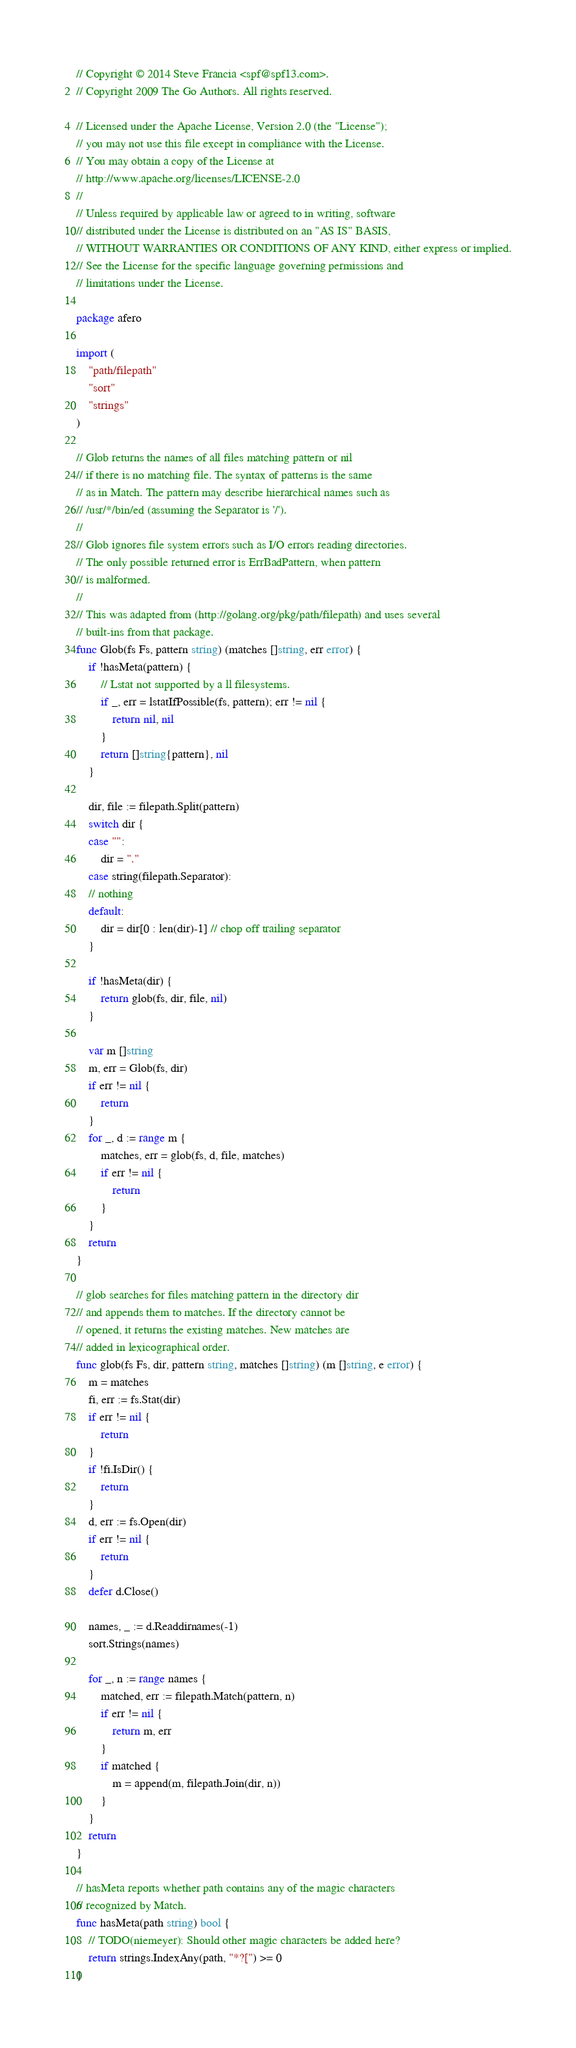Convert code to text. <code><loc_0><loc_0><loc_500><loc_500><_Go_>// Copyright © 2014 Steve Francia <spf@spf13.com>.
// Copyright 2009 The Go Authors. All rights reserved.

// Licensed under the Apache License, Version 2.0 (the "License");
// you may not use this file except in compliance with the License.
// You may obtain a copy of the License at
// http://www.apache.org/licenses/LICENSE-2.0
//
// Unless required by applicable law or agreed to in writing, software
// distributed under the License is distributed on an "AS IS" BASIS,
// WITHOUT WARRANTIES OR CONDITIONS OF ANY KIND, either express or implied.
// See the License for the specific language governing permissions and
// limitations under the License.

package afero

import (
	"path/filepath"
	"sort"
	"strings"
)

// Glob returns the names of all files matching pattern or nil
// if there is no matching file. The syntax of patterns is the same
// as in Match. The pattern may describe hierarchical names such as
// /usr/*/bin/ed (assuming the Separator is '/').
//
// Glob ignores file system errors such as I/O errors reading directories.
// The only possible returned error is ErrBadPattern, when pattern
// is malformed.
//
// This was adapted from (http://golang.org/pkg/path/filepath) and uses several
// built-ins from that package.
func Glob(fs Fs, pattern string) (matches []string, err error) {
	if !hasMeta(pattern) {
		// Lstat not supported by a ll filesystems.
		if _, err = lstatIfPossible(fs, pattern); err != nil {
			return nil, nil
		}
		return []string{pattern}, nil
	}

	dir, file := filepath.Split(pattern)
	switch dir {
	case "":
		dir = "."
	case string(filepath.Separator):
	// nothing
	default:
		dir = dir[0 : len(dir)-1] // chop off trailing separator
	}

	if !hasMeta(dir) {
		return glob(fs, dir, file, nil)
	}

	var m []string
	m, err = Glob(fs, dir)
	if err != nil {
		return
	}
	for _, d := range m {
		matches, err = glob(fs, d, file, matches)
		if err != nil {
			return
		}
	}
	return
}

// glob searches for files matching pattern in the directory dir
// and appends them to matches. If the directory cannot be
// opened, it returns the existing matches. New matches are
// added in lexicographical order.
func glob(fs Fs, dir, pattern string, matches []string) (m []string, e error) {
	m = matches
	fi, err := fs.Stat(dir)
	if err != nil {
		return
	}
	if !fi.IsDir() {
		return
	}
	d, err := fs.Open(dir)
	if err != nil {
		return
	}
	defer d.Close()

	names, _ := d.Readdirnames(-1)
	sort.Strings(names)

	for _, n := range names {
		matched, err := filepath.Match(pattern, n)
		if err != nil {
			return m, err
		}
		if matched {
			m = append(m, filepath.Join(dir, n))
		}
	}
	return
}

// hasMeta reports whether path contains any of the magic characters
// recognized by Match.
func hasMeta(path string) bool {
	// TODO(niemeyer): Should other magic characters be added here?
	return strings.IndexAny(path, "*?[") >= 0
}
</code> 